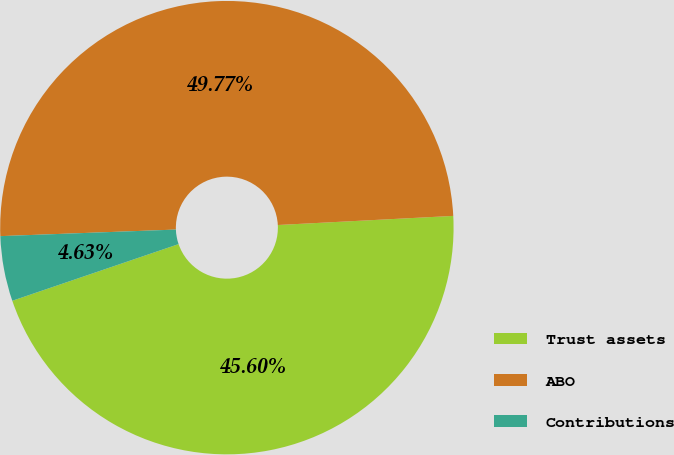Convert chart to OTSL. <chart><loc_0><loc_0><loc_500><loc_500><pie_chart><fcel>Trust assets<fcel>ABO<fcel>Contributions<nl><fcel>45.6%<fcel>49.77%<fcel>4.63%<nl></chart> 